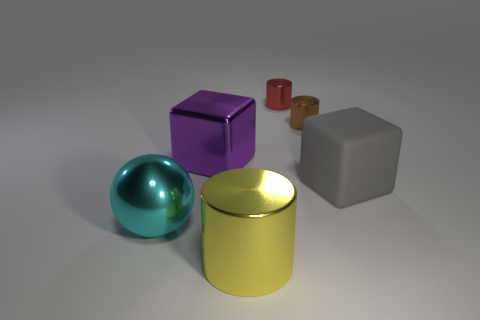There is a large block that is right of the block on the left side of the gray matte thing; what is its material?
Provide a short and direct response. Rubber. Does the red thing have the same shape as the metallic thing in front of the cyan sphere?
Your response must be concise. Yes. How many rubber things are either purple objects or brown cylinders?
Keep it short and to the point. 0. The shiny cylinder that is in front of the large cube that is right of the small object behind the tiny brown shiny thing is what color?
Provide a short and direct response. Yellow. What number of other objects are there of the same material as the tiny red object?
Offer a very short reply. 4. Does the large shiny object that is behind the gray object have the same shape as the small red metallic thing?
Make the answer very short. No. How many small objects are balls or gray balls?
Make the answer very short. 0. Is the number of objects that are on the right side of the big purple thing the same as the number of blocks to the left of the tiny brown thing?
Your answer should be very brief. No. What number of other things are there of the same color as the large shiny cylinder?
Make the answer very short. 0. Does the rubber cube have the same color as the large cube that is to the left of the brown thing?
Your response must be concise. No. 